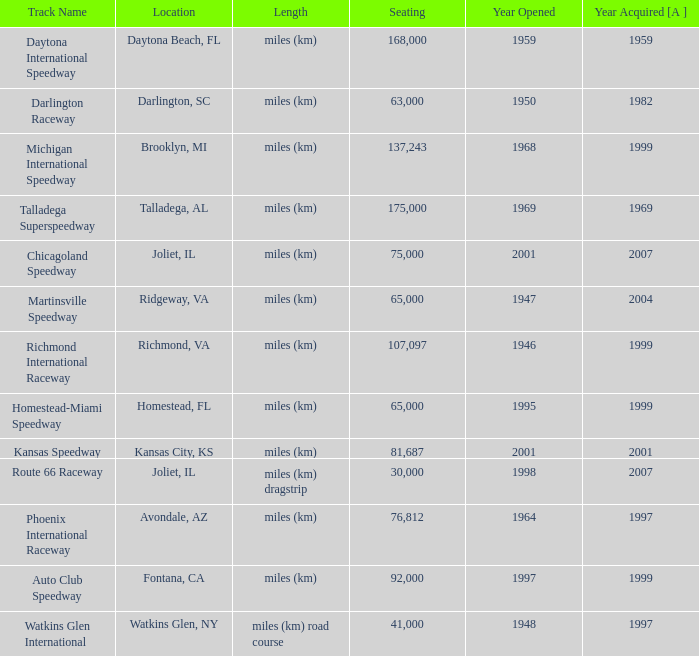What is the year opened for Chicagoland Speedway with a seating smaller than 75,000? None. Give me the full table as a dictionary. {'header': ['Track Name', 'Location', 'Length', 'Seating', 'Year Opened', 'Year Acquired [A ]'], 'rows': [['Daytona International Speedway', 'Daytona Beach, FL', 'miles (km)', '168,000', '1959', '1959'], ['Darlington Raceway', 'Darlington, SC', 'miles (km)', '63,000', '1950', '1982'], ['Michigan International Speedway', 'Brooklyn, MI', 'miles (km)', '137,243', '1968', '1999'], ['Talladega Superspeedway', 'Talladega, AL', 'miles (km)', '175,000', '1969', '1969'], ['Chicagoland Speedway', 'Joliet, IL', 'miles (km)', '75,000', '2001', '2007'], ['Martinsville Speedway', 'Ridgeway, VA', 'miles (km)', '65,000', '1947', '2004'], ['Richmond International Raceway', 'Richmond, VA', 'miles (km)', '107,097', '1946', '1999'], ['Homestead-Miami Speedway', 'Homestead, FL', 'miles (km)', '65,000', '1995', '1999'], ['Kansas Speedway', 'Kansas City, KS', 'miles (km)', '81,687', '2001', '2001'], ['Route 66 Raceway', 'Joliet, IL', 'miles (km) dragstrip', '30,000', '1998', '2007'], ['Phoenix International Raceway', 'Avondale, AZ', 'miles (km)', '76,812', '1964', '1997'], ['Auto Club Speedway', 'Fontana, CA', 'miles (km)', '92,000', '1997', '1999'], ['Watkins Glen International', 'Watkins Glen, NY', 'miles (km) road course', '41,000', '1948', '1997']]} 